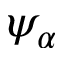Convert formula to latex. <formula><loc_0><loc_0><loc_500><loc_500>\psi _ { \alpha }</formula> 